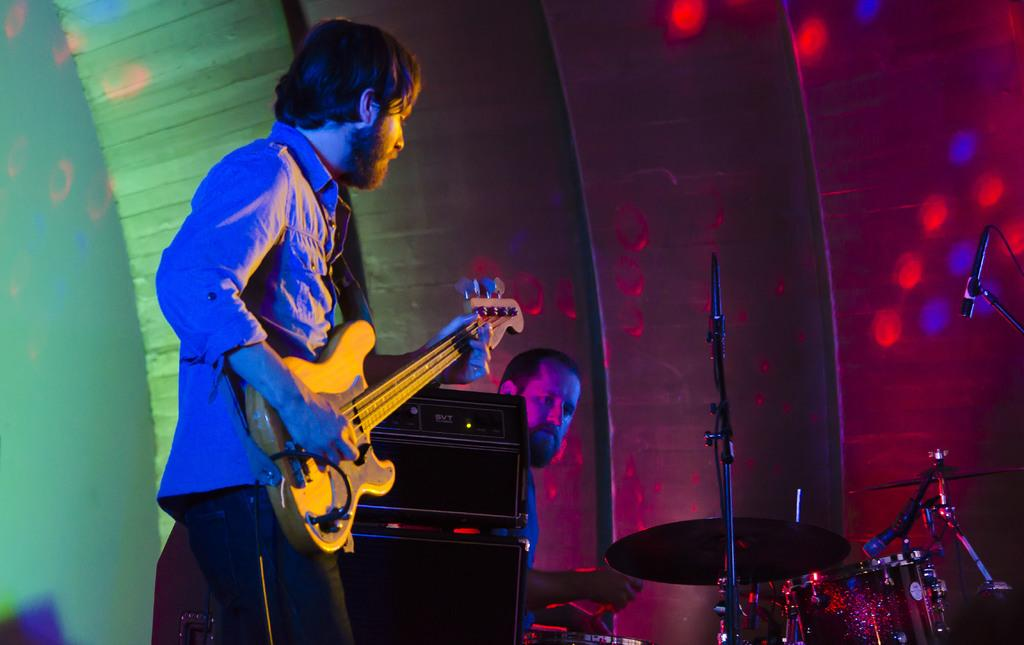What is the main subject of the image? The main subject of the image is a man standing and playing a guitar. Are there any other musicians in the image? Yes, there is a man playing drums beside the speaker. What can be seen beside the guitarist? There is a speaker beside the guitarist. What is happening in the background of the image? Colorful lights are flashing on the wall behind the musicians. What is the weather like in the hospital where the musicians are performing? There is no information about a hospital or the weather in the image. The image features musicians playing instruments and colorful lights in the background. 